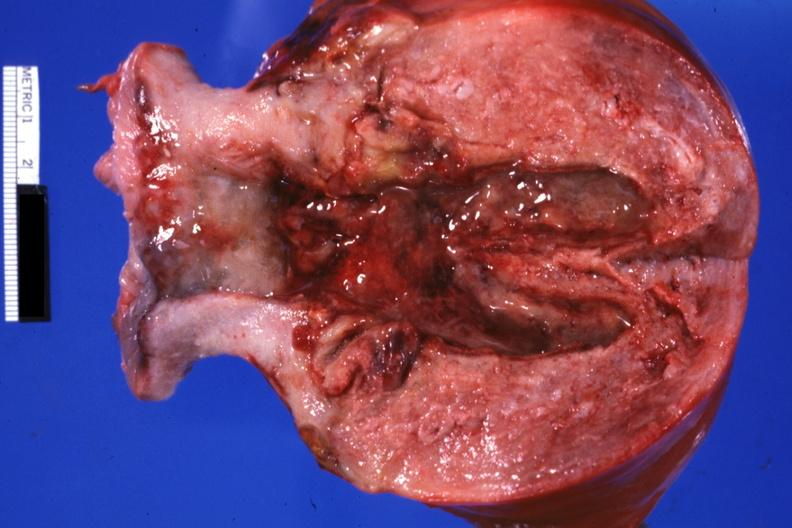s cranial artery present?
Answer the question using a single word or phrase. No 